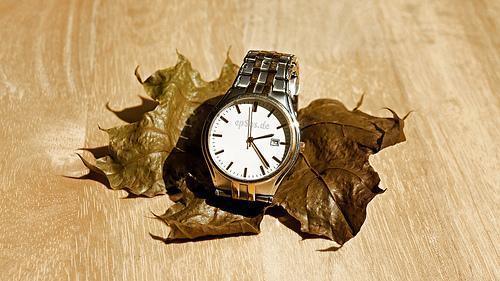How many watches are in the photo?
Give a very brief answer. 1. 